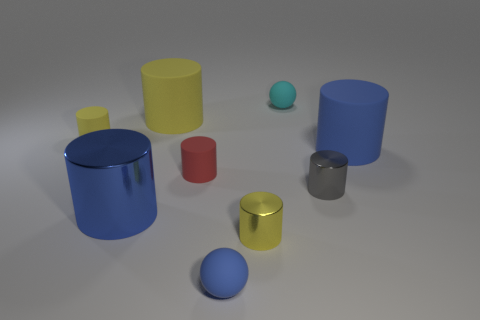Are there any patterns or textures observed on the surface of these objects? The objects appear to have smooth surfaces without any discernible patterns or textures. The absence of intricate details suggests a focus on the purity of geometric form and the interplay of light and color. Could these objects be part of a visual study in a certain field? Yes, they could be part of a study in computer graphics, focusing on rendering techniques, or used as educational tools in a physics class to discuss topics like light, color, and optics. 